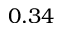Convert formula to latex. <formula><loc_0><loc_0><loc_500><loc_500>0 . 3 4</formula> 